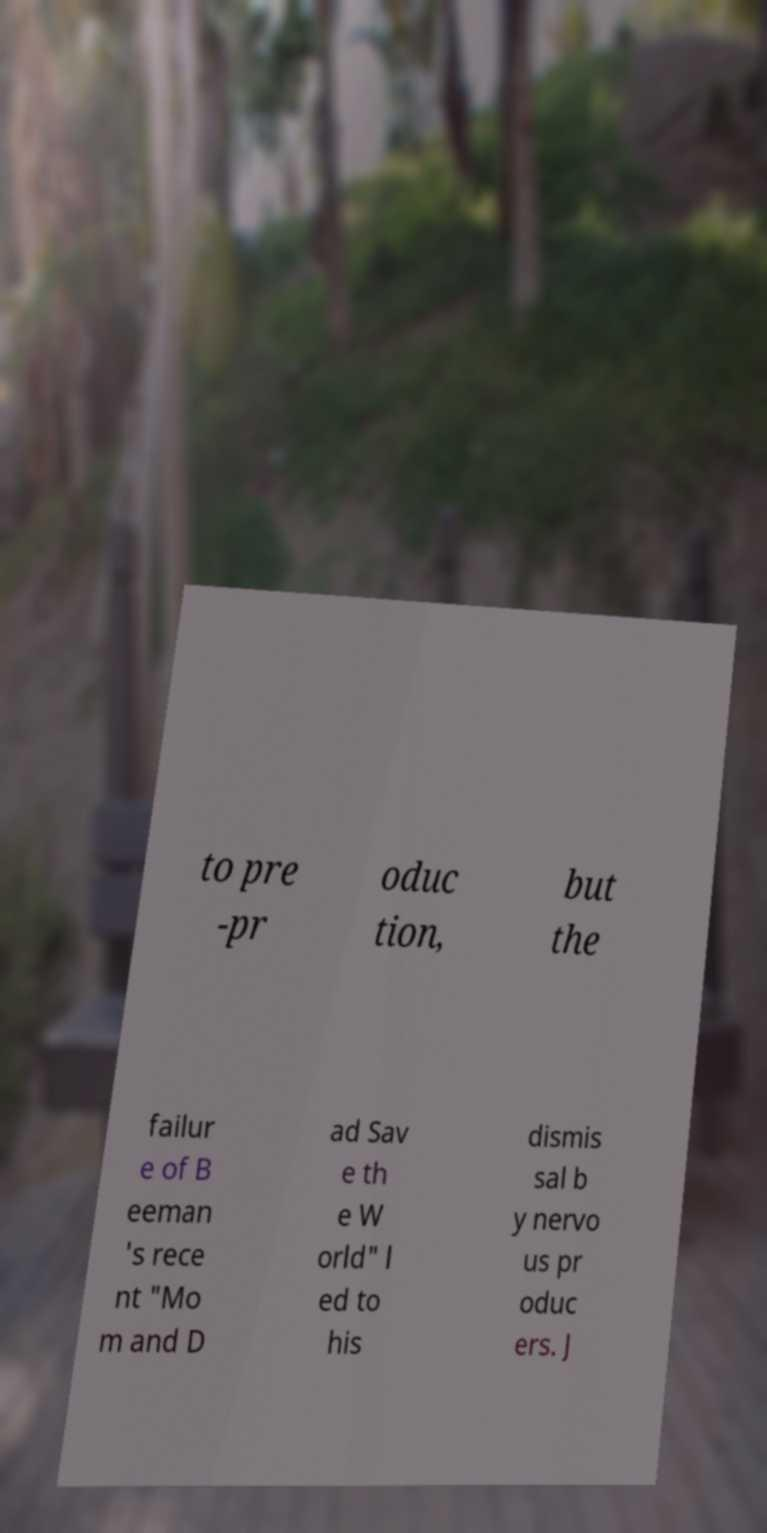Please read and relay the text visible in this image. What does it say? to pre -pr oduc tion, but the failur e of B eeman 's rece nt "Mo m and D ad Sav e th e W orld" l ed to his dismis sal b y nervo us pr oduc ers. J 